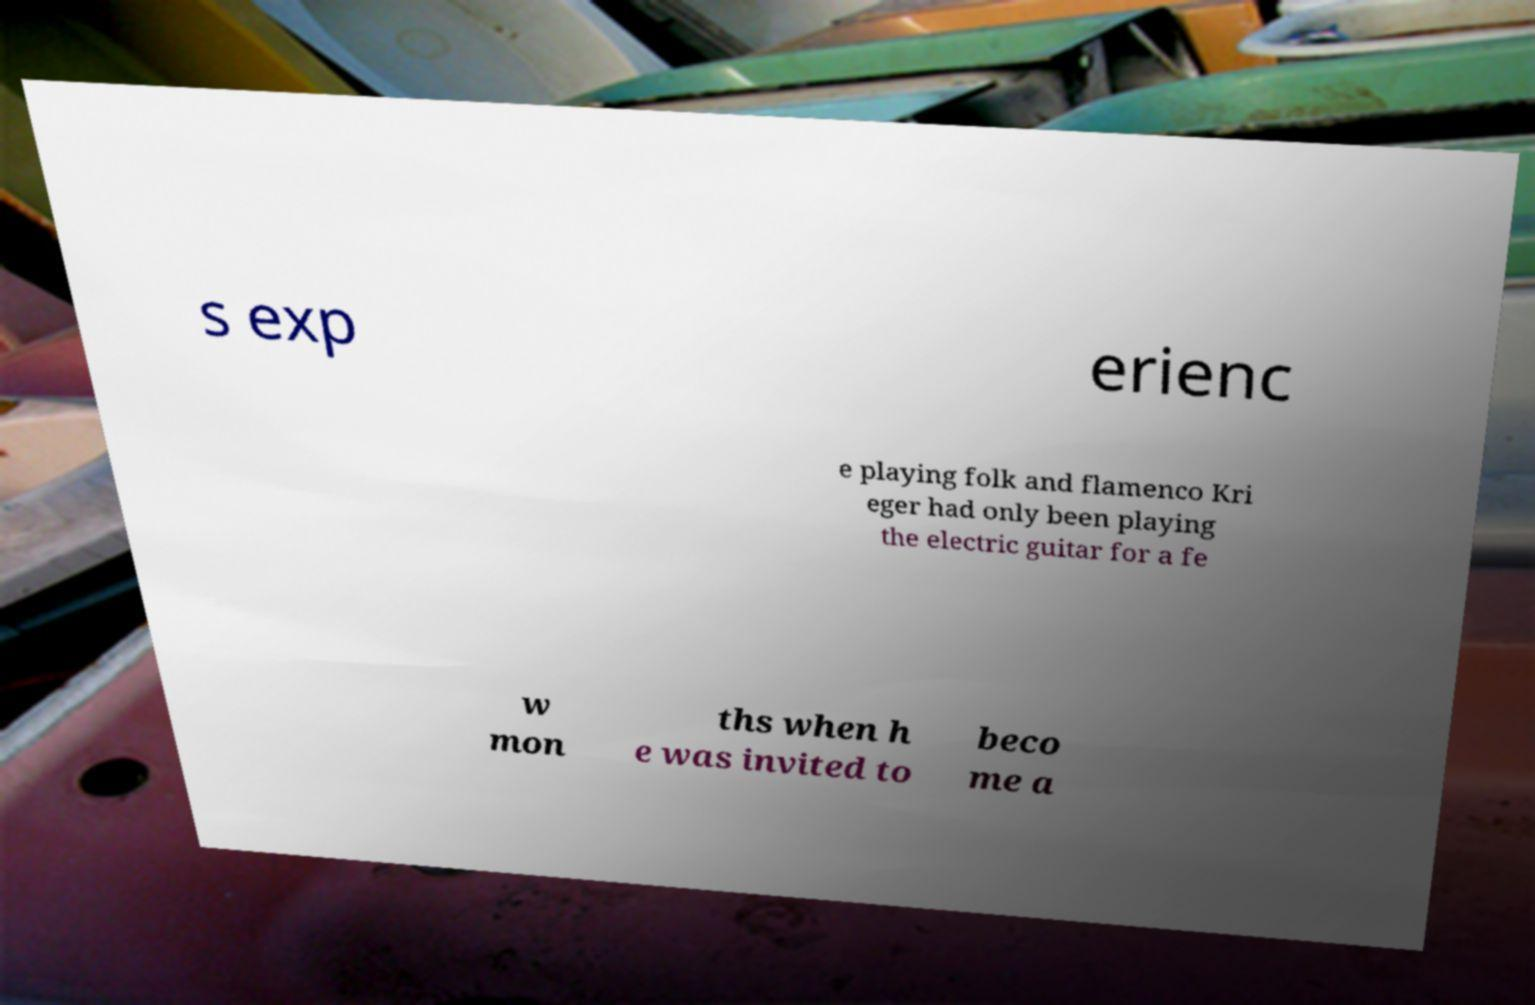Please read and relay the text visible in this image. What does it say? s exp erienc e playing folk and flamenco Kri eger had only been playing the electric guitar for a fe w mon ths when h e was invited to beco me a 